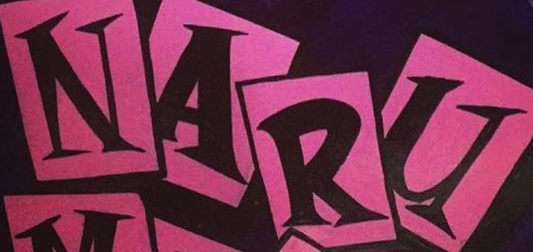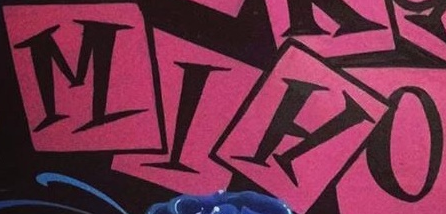Read the text from these images in sequence, separated by a semicolon. NARU; MIHO 